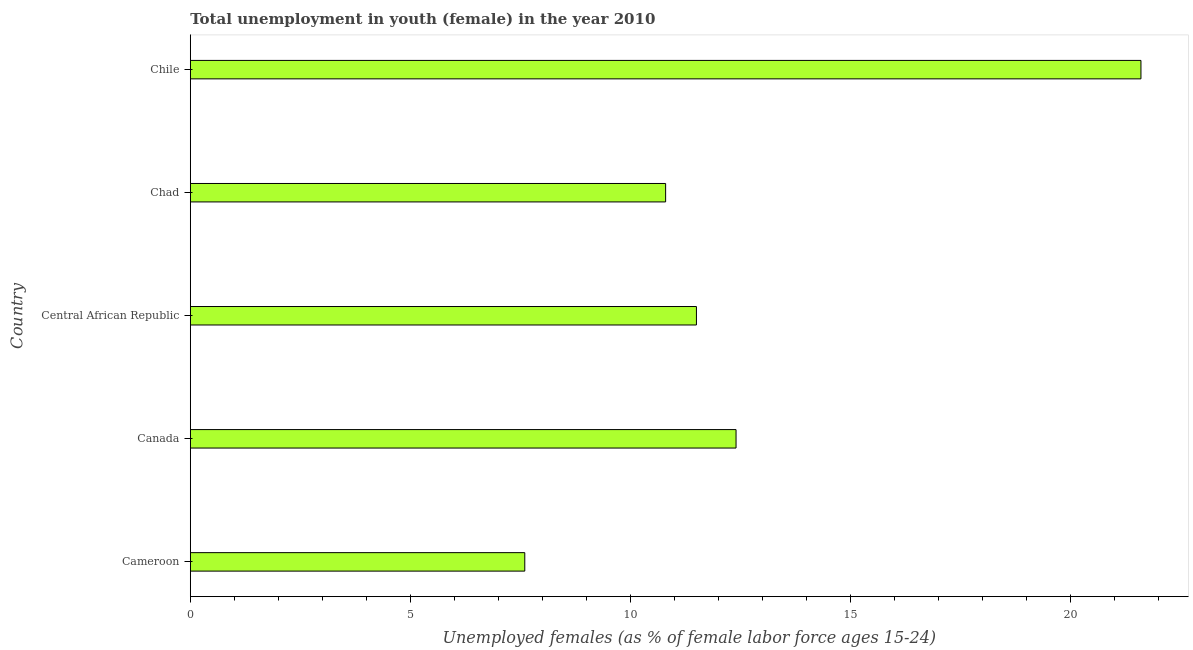Does the graph contain any zero values?
Provide a succinct answer. No. Does the graph contain grids?
Your response must be concise. No. What is the title of the graph?
Keep it short and to the point. Total unemployment in youth (female) in the year 2010. What is the label or title of the X-axis?
Provide a short and direct response. Unemployed females (as % of female labor force ages 15-24). What is the unemployed female youth population in Cameroon?
Provide a short and direct response. 7.6. Across all countries, what is the maximum unemployed female youth population?
Keep it short and to the point. 21.6. Across all countries, what is the minimum unemployed female youth population?
Keep it short and to the point. 7.6. In which country was the unemployed female youth population maximum?
Give a very brief answer. Chile. In which country was the unemployed female youth population minimum?
Provide a short and direct response. Cameroon. What is the sum of the unemployed female youth population?
Your response must be concise. 63.9. What is the difference between the unemployed female youth population in Cameroon and Chile?
Ensure brevity in your answer.  -14. What is the average unemployed female youth population per country?
Ensure brevity in your answer.  12.78. What is the median unemployed female youth population?
Offer a very short reply. 11.5. What is the ratio of the unemployed female youth population in Canada to that in Chad?
Provide a short and direct response. 1.15. Is the unemployed female youth population in Canada less than that in Chad?
Your answer should be compact. No. Is the difference between the unemployed female youth population in Central African Republic and Chad greater than the difference between any two countries?
Keep it short and to the point. No. Is the sum of the unemployed female youth population in Cameroon and Central African Republic greater than the maximum unemployed female youth population across all countries?
Your answer should be very brief. No. In how many countries, is the unemployed female youth population greater than the average unemployed female youth population taken over all countries?
Keep it short and to the point. 1. How many bars are there?
Keep it short and to the point. 5. Are all the bars in the graph horizontal?
Offer a terse response. Yes. What is the Unemployed females (as % of female labor force ages 15-24) of Cameroon?
Give a very brief answer. 7.6. What is the Unemployed females (as % of female labor force ages 15-24) of Canada?
Provide a succinct answer. 12.4. What is the Unemployed females (as % of female labor force ages 15-24) of Chad?
Ensure brevity in your answer.  10.8. What is the Unemployed females (as % of female labor force ages 15-24) of Chile?
Ensure brevity in your answer.  21.6. What is the difference between the Unemployed females (as % of female labor force ages 15-24) in Cameroon and Chad?
Provide a short and direct response. -3.2. What is the difference between the Unemployed females (as % of female labor force ages 15-24) in Cameroon and Chile?
Make the answer very short. -14. What is the difference between the Unemployed females (as % of female labor force ages 15-24) in Canada and Chile?
Offer a very short reply. -9.2. What is the difference between the Unemployed females (as % of female labor force ages 15-24) in Central African Republic and Chile?
Your response must be concise. -10.1. What is the difference between the Unemployed females (as % of female labor force ages 15-24) in Chad and Chile?
Your answer should be compact. -10.8. What is the ratio of the Unemployed females (as % of female labor force ages 15-24) in Cameroon to that in Canada?
Your response must be concise. 0.61. What is the ratio of the Unemployed females (as % of female labor force ages 15-24) in Cameroon to that in Central African Republic?
Your answer should be very brief. 0.66. What is the ratio of the Unemployed females (as % of female labor force ages 15-24) in Cameroon to that in Chad?
Give a very brief answer. 0.7. What is the ratio of the Unemployed females (as % of female labor force ages 15-24) in Cameroon to that in Chile?
Offer a terse response. 0.35. What is the ratio of the Unemployed females (as % of female labor force ages 15-24) in Canada to that in Central African Republic?
Offer a terse response. 1.08. What is the ratio of the Unemployed females (as % of female labor force ages 15-24) in Canada to that in Chad?
Your answer should be compact. 1.15. What is the ratio of the Unemployed females (as % of female labor force ages 15-24) in Canada to that in Chile?
Ensure brevity in your answer.  0.57. What is the ratio of the Unemployed females (as % of female labor force ages 15-24) in Central African Republic to that in Chad?
Provide a succinct answer. 1.06. What is the ratio of the Unemployed females (as % of female labor force ages 15-24) in Central African Republic to that in Chile?
Give a very brief answer. 0.53. What is the ratio of the Unemployed females (as % of female labor force ages 15-24) in Chad to that in Chile?
Offer a very short reply. 0.5. 